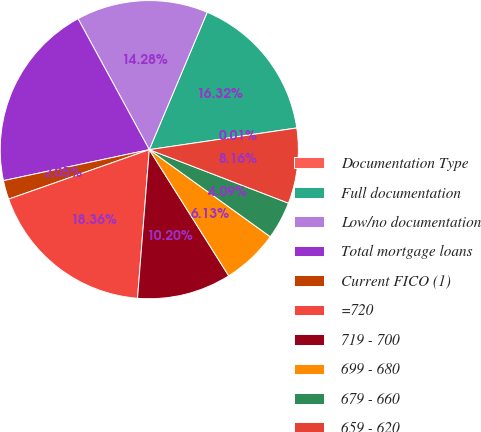Convert chart to OTSL. <chart><loc_0><loc_0><loc_500><loc_500><pie_chart><fcel>Documentation Type<fcel>Full documentation<fcel>Low/no documentation<fcel>Total mortgage loans<fcel>Current FICO (1)<fcel>=720<fcel>719 - 700<fcel>699 - 680<fcel>679 - 660<fcel>659 - 620<nl><fcel>0.01%<fcel>16.32%<fcel>14.28%<fcel>20.4%<fcel>2.05%<fcel>18.36%<fcel>10.2%<fcel>6.13%<fcel>4.09%<fcel>8.16%<nl></chart> 